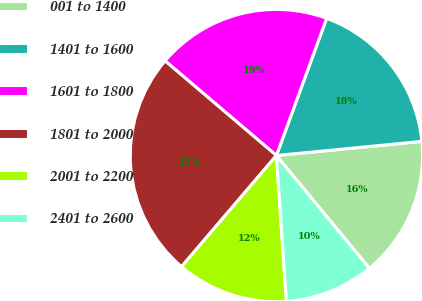Convert chart. <chart><loc_0><loc_0><loc_500><loc_500><pie_chart><fcel>001 to 1400<fcel>1401 to 1600<fcel>1601 to 1800<fcel>1801 to 2000<fcel>2001 to 2200<fcel>2401 to 2600<nl><fcel>15.57%<fcel>17.87%<fcel>19.37%<fcel>24.97%<fcel>12.34%<fcel>9.88%<nl></chart> 